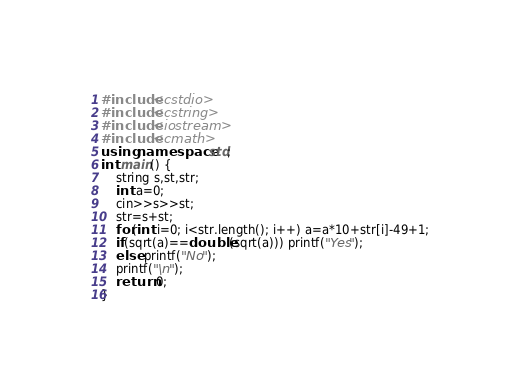<code> <loc_0><loc_0><loc_500><loc_500><_C++_>#include<cstdio>
#include<cstring>
#include<iostream>
#include<cmath>
using namespace std;
int main() {
	string s,st,str;
	int a=0;
	cin>>s>>st;
	str=s+st;
	for(int i=0; i<str.length(); i++) a=a*10+str[i]-49+1;
	if(sqrt(a)==double(sqrt(a))) printf("Yes");
	else printf("No");
	printf("\n");
	return 0;
}</code> 